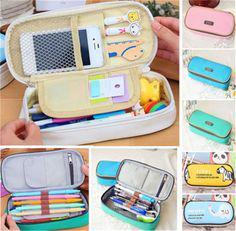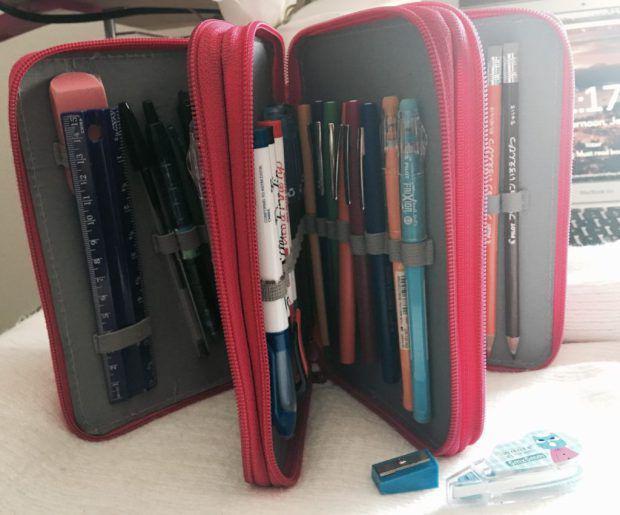The first image is the image on the left, the second image is the image on the right. Examine the images to the left and right. Is the description "An open pencil case contains at least one stick-shaped item with a cartoony face shape on the end." accurate? Answer yes or no. Yes. The first image is the image on the left, the second image is the image on the right. For the images shown, is this caption "A person is holding a pencil case with one hand in the image on the left." true? Answer yes or no. No. 